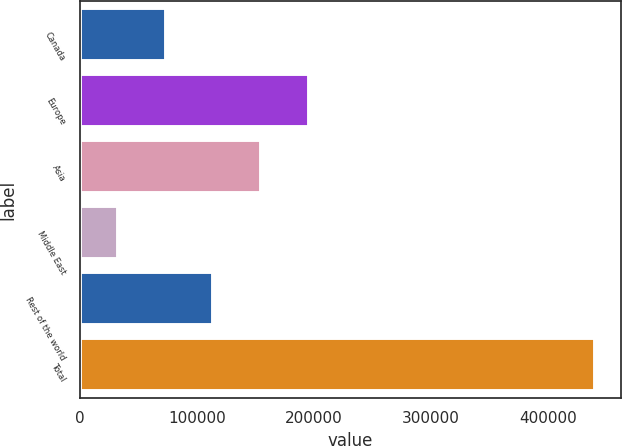Convert chart. <chart><loc_0><loc_0><loc_500><loc_500><bar_chart><fcel>Canada<fcel>Europe<fcel>Asia<fcel>Middle East<fcel>Rest of the world<fcel>Total<nl><fcel>73239.7<fcel>195627<fcel>154831<fcel>32444<fcel>114035<fcel>440401<nl></chart> 